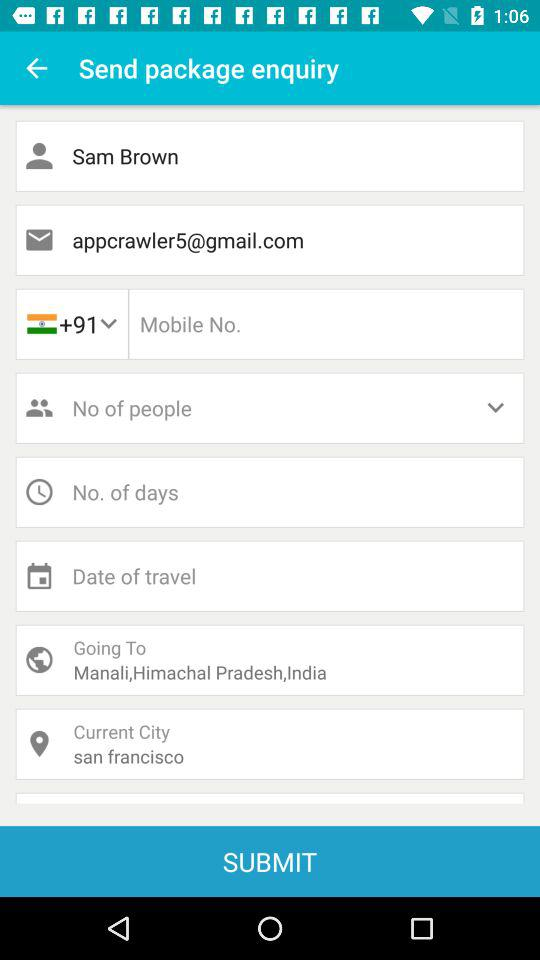What is the name? The name is Sam Brown. 